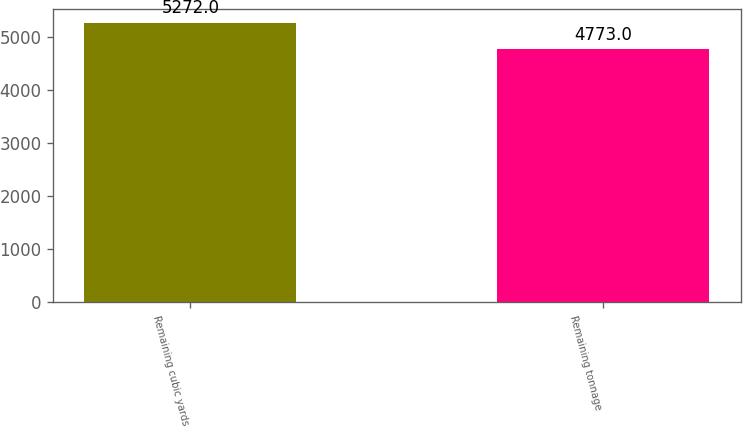<chart> <loc_0><loc_0><loc_500><loc_500><bar_chart><fcel>Remaining cubic yards<fcel>Remaining tonnage<nl><fcel>5272<fcel>4773<nl></chart> 